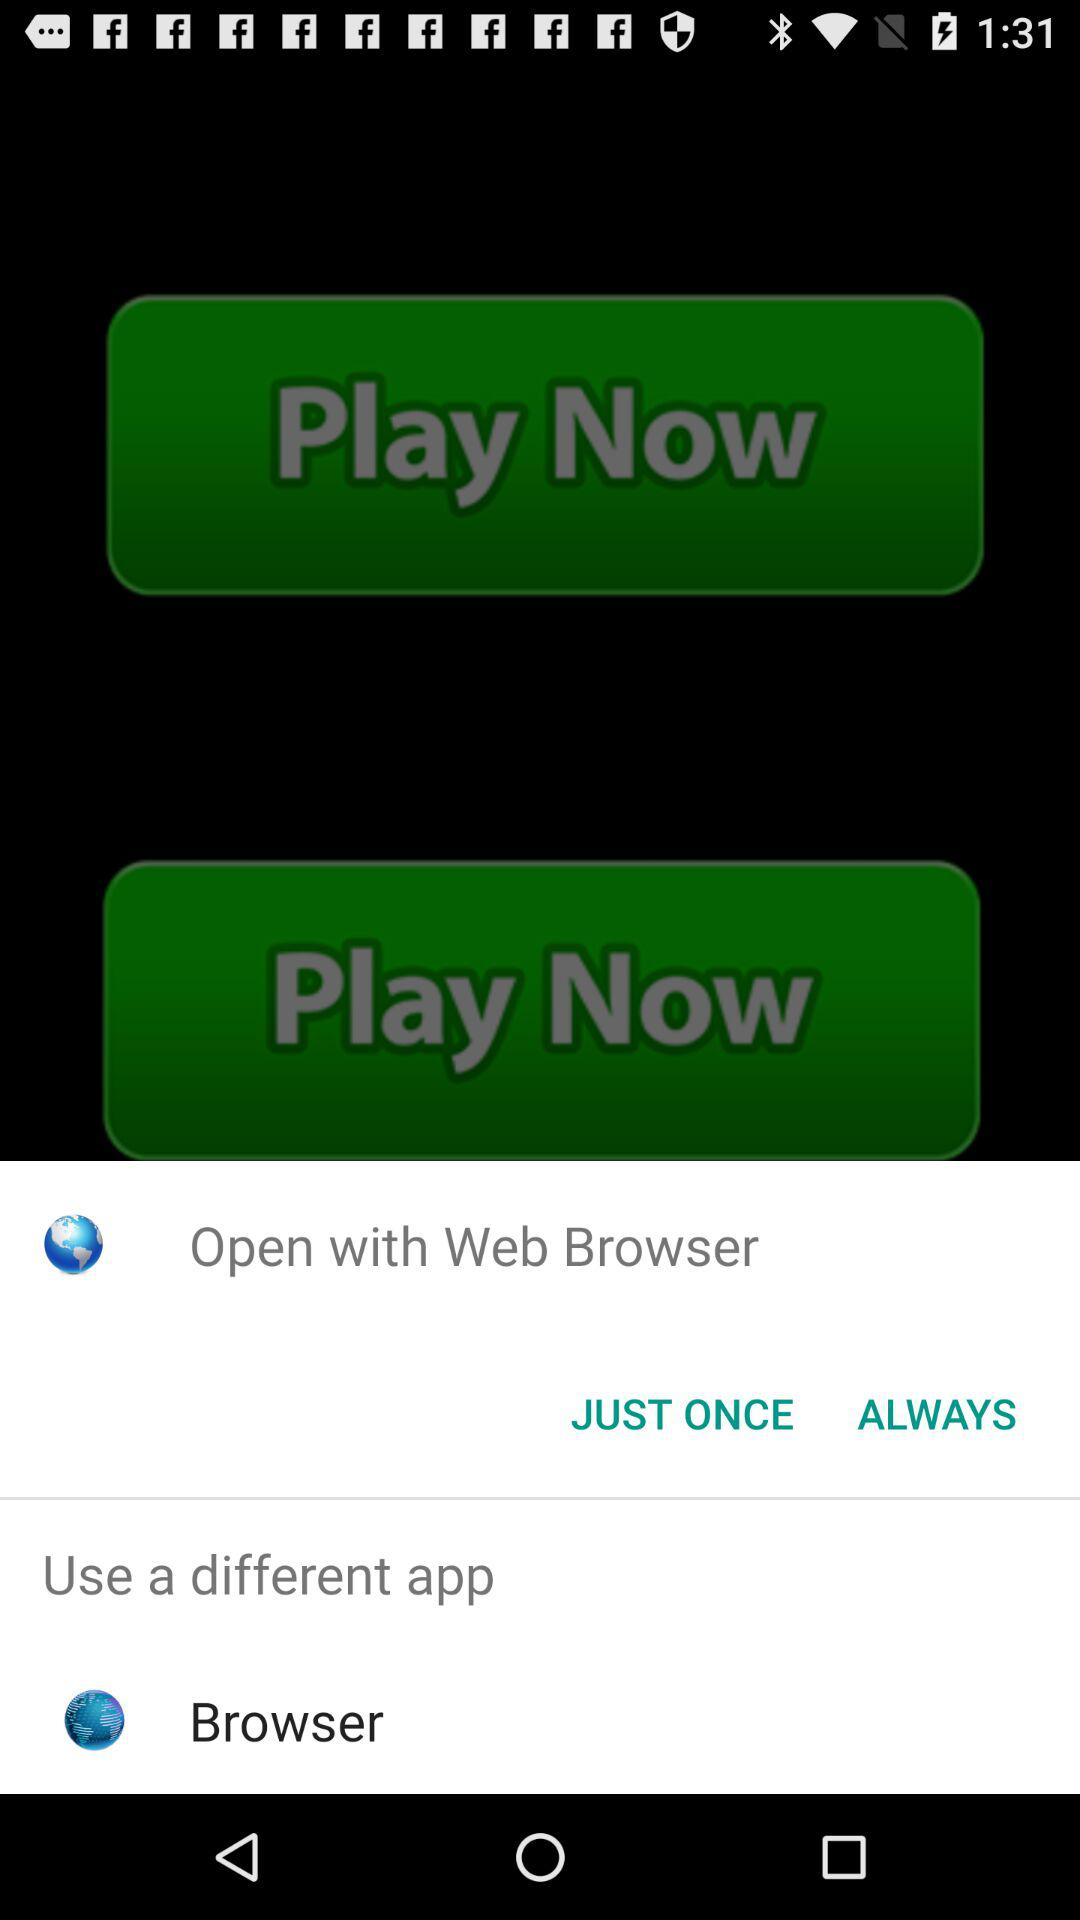What is the name of the application?
When the provided information is insufficient, respond with <no answer>. <no answer> 